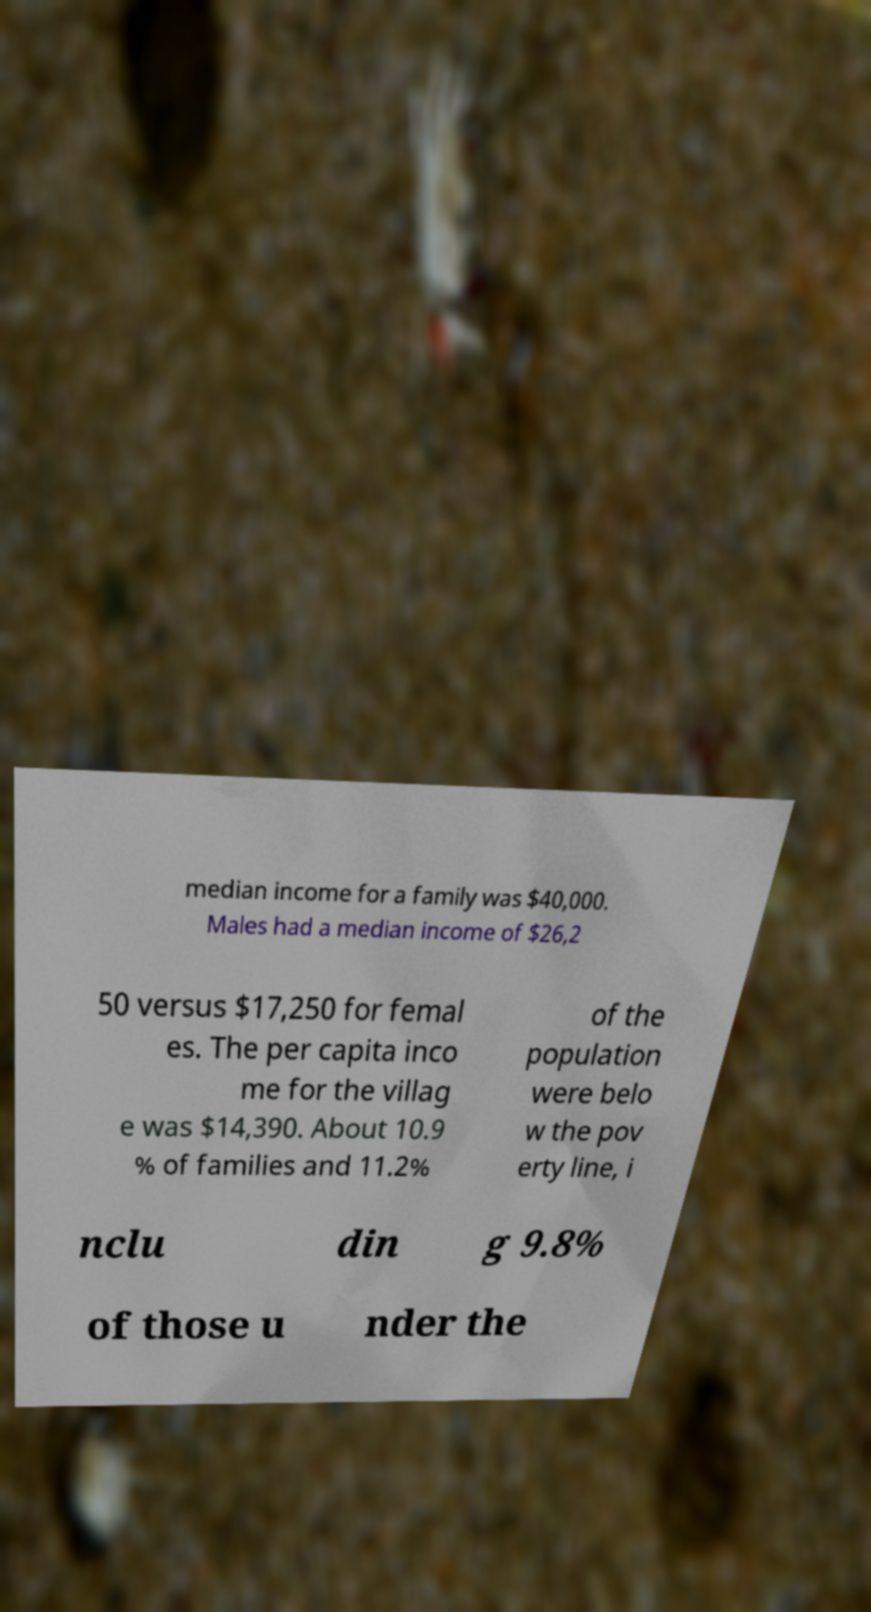Could you extract and type out the text from this image? median income for a family was $40,000. Males had a median income of $26,2 50 versus $17,250 for femal es. The per capita inco me for the villag e was $14,390. About 10.9 % of families and 11.2% of the population were belo w the pov erty line, i nclu din g 9.8% of those u nder the 